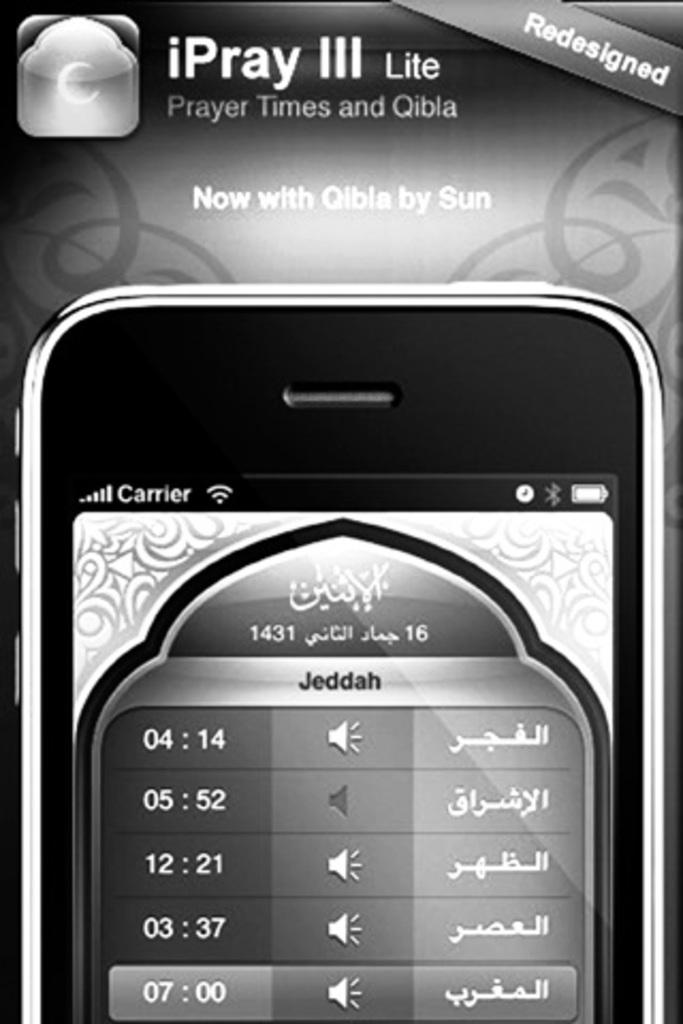<image>
Give a short and clear explanation of the subsequent image. a phone for iPray III lite that shows Prayer Times and Qibla 